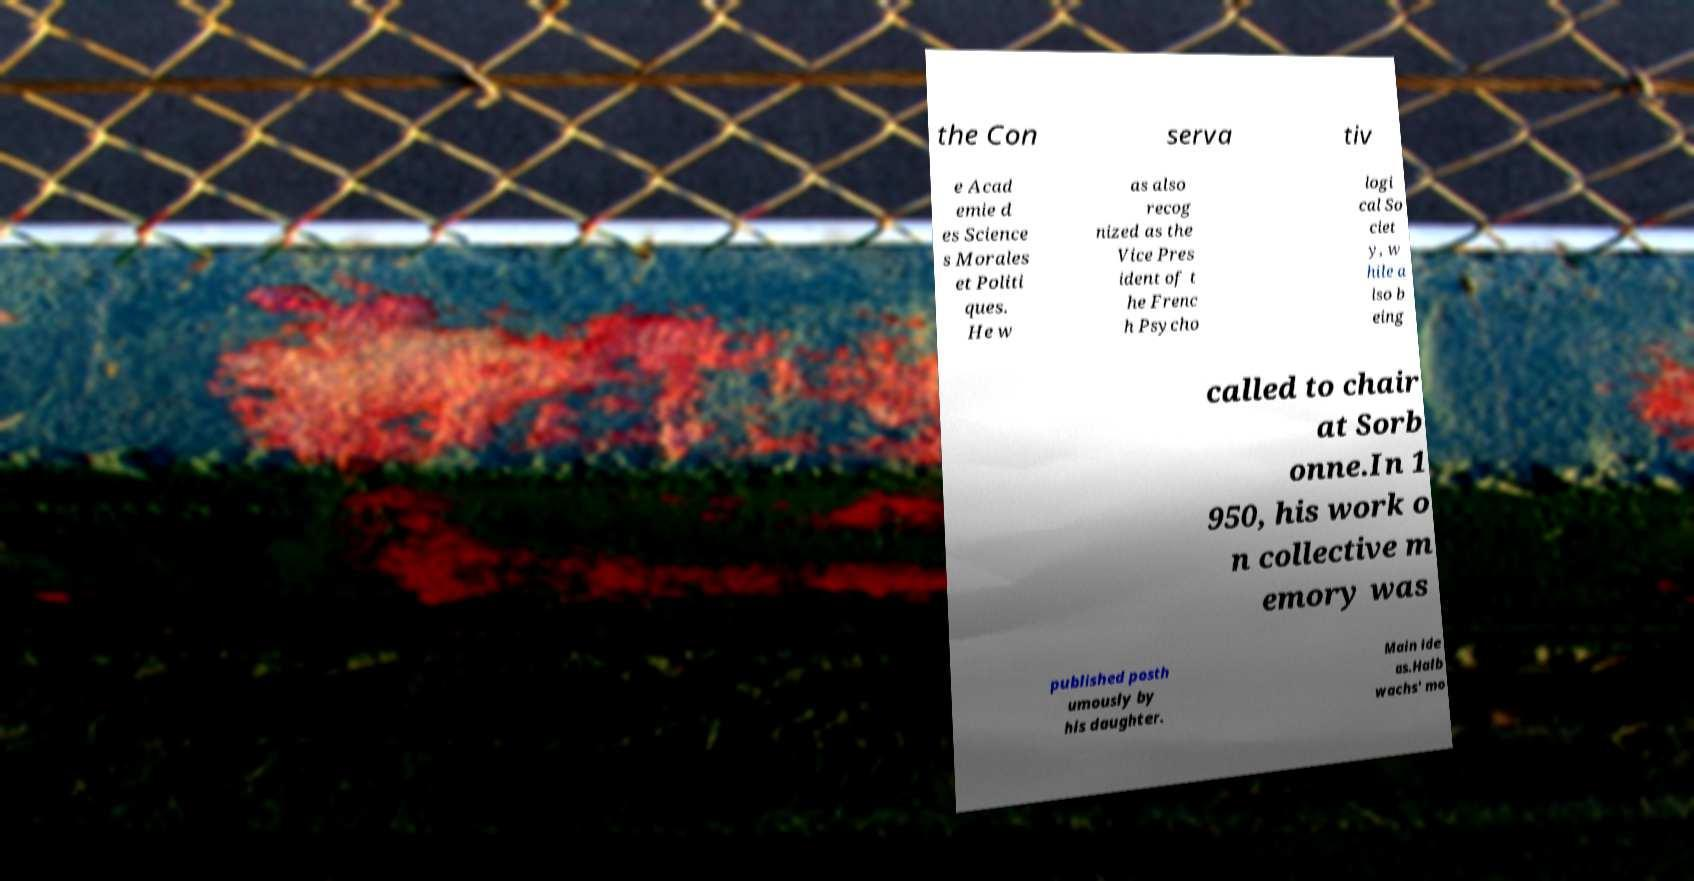Could you extract and type out the text from this image? the Con serva tiv e Acad emie d es Science s Morales et Politi ques. He w as also recog nized as the Vice Pres ident of t he Frenc h Psycho logi cal So ciet y, w hile a lso b eing called to chair at Sorb onne.In 1 950, his work o n collective m emory was published posth umously by his daughter. Main ide as.Halb wachs' mo 